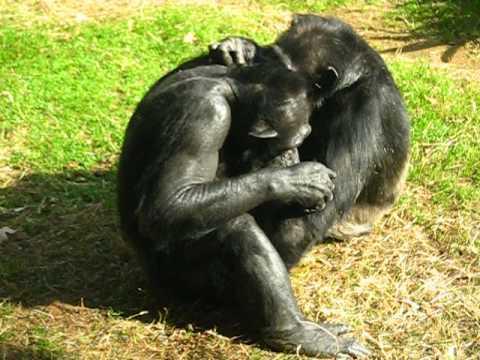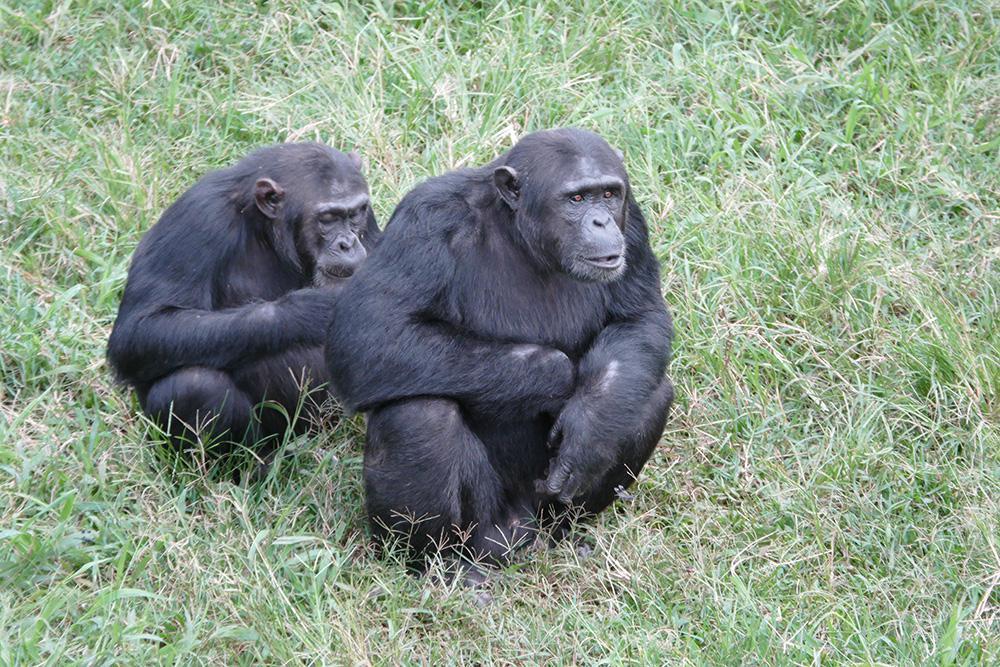The first image is the image on the left, the second image is the image on the right. Assess this claim about the two images: "The right image contains exactly two chimpanzees.". Correct or not? Answer yes or no. Yes. The first image is the image on the left, the second image is the image on the right. Analyze the images presented: Is the assertion "Each image shows exactly two chimps sitting close together, and at least one image shows a chimp grooming the fur of the other." valid? Answer yes or no. Yes. 